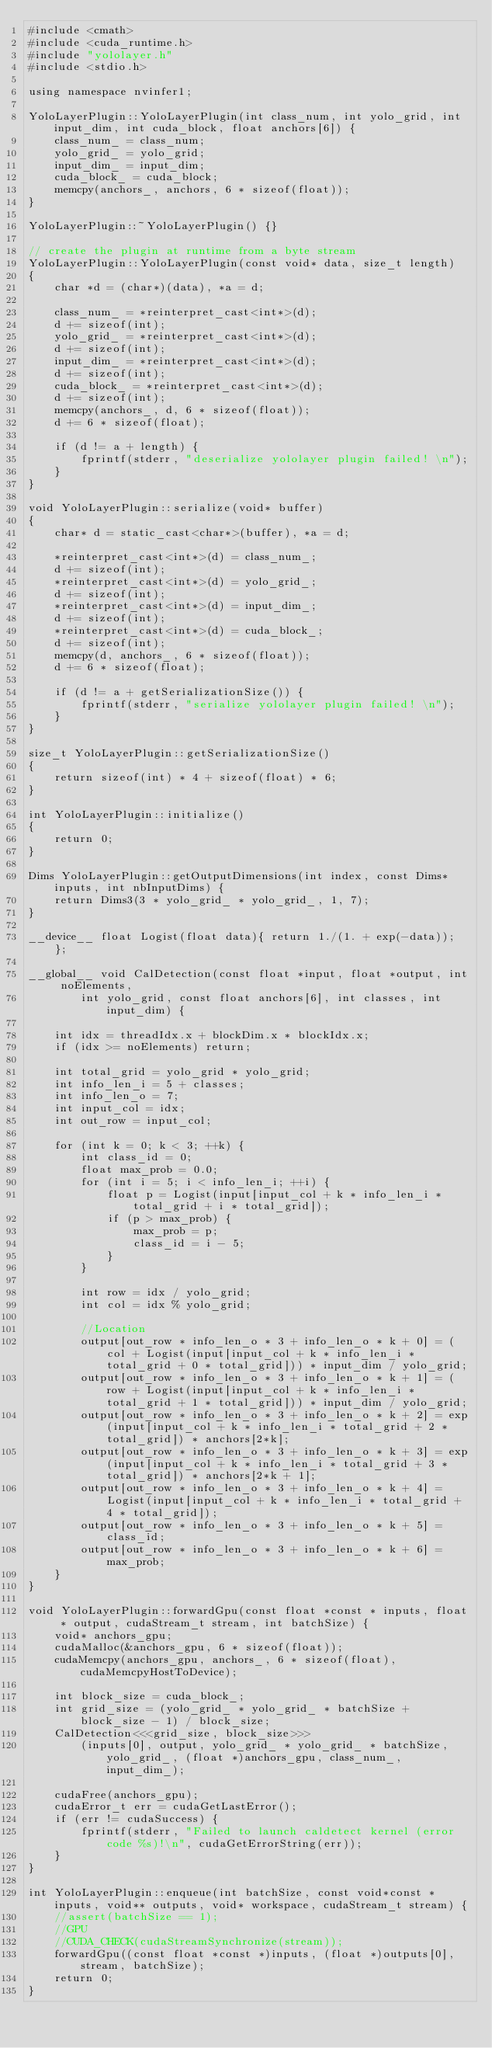Convert code to text. <code><loc_0><loc_0><loc_500><loc_500><_Cuda_>#include <cmath>
#include <cuda_runtime.h>
#include "yololayer.h"
#include <stdio.h>

using namespace nvinfer1;

YoloLayerPlugin::YoloLayerPlugin(int class_num, int yolo_grid, int input_dim, int cuda_block, float anchors[6]) {
    class_num_ = class_num;
    yolo_grid_ = yolo_grid;
    input_dim_ = input_dim;
    cuda_block_ = cuda_block;
    memcpy(anchors_, anchors, 6 * sizeof(float));
}

YoloLayerPlugin::~YoloLayerPlugin() {}

// create the plugin at runtime from a byte stream
YoloLayerPlugin::YoloLayerPlugin(const void* data, size_t length)
{
    char *d = (char*)(data), *a = d;

    class_num_ = *reinterpret_cast<int*>(d);
    d += sizeof(int);
    yolo_grid_ = *reinterpret_cast<int*>(d);
    d += sizeof(int);
    input_dim_ = *reinterpret_cast<int*>(d);
    d += sizeof(int);
    cuda_block_ = *reinterpret_cast<int*>(d);
    d += sizeof(int);
    memcpy(anchors_, d, 6 * sizeof(float));
    d += 6 * sizeof(float);

    if (d != a + length) {
        fprintf(stderr, "deserialize yololayer plugin failed! \n");
    }
}

void YoloLayerPlugin::serialize(void* buffer)
{
    char* d = static_cast<char*>(buffer), *a = d;

    *reinterpret_cast<int*>(d) = class_num_;
    d += sizeof(int);
    *reinterpret_cast<int*>(d) = yolo_grid_;
    d += sizeof(int);
    *reinterpret_cast<int*>(d) = input_dim_;
    d += sizeof(int);
    *reinterpret_cast<int*>(d) = cuda_block_;
    d += sizeof(int);
    memcpy(d, anchors_, 6 * sizeof(float));
    d += 6 * sizeof(float);

    if (d != a + getSerializationSize()) {
        fprintf(stderr, "serialize yololayer plugin failed! \n");
    }
}

size_t YoloLayerPlugin::getSerializationSize()
{  
    return sizeof(int) * 4 + sizeof(float) * 6;
}

int YoloLayerPlugin::initialize()
{ 
    return 0;
}

Dims YoloLayerPlugin::getOutputDimensions(int index, const Dims* inputs, int nbInputDims) {
    return Dims3(3 * yolo_grid_ * yolo_grid_, 1, 7);
}

__device__ float Logist(float data){ return 1./(1. + exp(-data)); };

__global__ void CalDetection(const float *input, float *output, int noElements,
        int yolo_grid, const float anchors[6], int classes, int input_dim) {

    int idx = threadIdx.x + blockDim.x * blockIdx.x;
    if (idx >= noElements) return;

    int total_grid = yolo_grid * yolo_grid;
    int info_len_i = 5 + classes;
    int info_len_o = 7;
    int input_col = idx;
    int out_row = input_col;

    for (int k = 0; k < 3; ++k) {
        int class_id = 0;
        float max_prob = 0.0;
        for (int i = 5; i < info_len_i; ++i) {
            float p = Logist(input[input_col + k * info_len_i * total_grid + i * total_grid]);
            if (p > max_prob) {
                max_prob = p;
                class_id = i - 5;
            }
        }

        int row = idx / yolo_grid;
        int col = idx % yolo_grid;

        //Location
        output[out_row * info_len_o * 3 + info_len_o * k + 0] = (col + Logist(input[input_col + k * info_len_i * total_grid + 0 * total_grid])) * input_dim / yolo_grid;
        output[out_row * info_len_o * 3 + info_len_o * k + 1] = (row + Logist(input[input_col + k * info_len_i * total_grid + 1 * total_grid])) * input_dim / yolo_grid;
        output[out_row * info_len_o * 3 + info_len_o * k + 2] = exp(input[input_col + k * info_len_i * total_grid + 2 * total_grid]) * anchors[2*k];
        output[out_row * info_len_o * 3 + info_len_o * k + 3] = exp(input[input_col + k * info_len_i * total_grid + 3 * total_grid]) * anchors[2*k + 1];
        output[out_row * info_len_o * 3 + info_len_o * k + 4] =  Logist(input[input_col + k * info_len_i * total_grid + 4 * total_grid]);
        output[out_row * info_len_o * 3 + info_len_o * k + 5] =  class_id;
        output[out_row * info_len_o * 3 + info_len_o * k + 6] =  max_prob;
    }
}

void YoloLayerPlugin::forwardGpu(const float *const * inputs, float * output, cudaStream_t stream, int batchSize) {
    void* anchors_gpu;
    cudaMalloc(&anchors_gpu, 6 * sizeof(float));
    cudaMemcpy(anchors_gpu, anchors_, 6 * sizeof(float), cudaMemcpyHostToDevice);

    int block_size = cuda_block_;
    int grid_size = (yolo_grid_ * yolo_grid_ * batchSize + block_size - 1) / block_size;
    CalDetection<<<grid_size, block_size>>>
        (inputs[0], output, yolo_grid_ * yolo_grid_ * batchSize, yolo_grid_, (float *)anchors_gpu, class_num_, input_dim_);

    cudaFree(anchors_gpu);
    cudaError_t err = cudaGetLastError();
    if (err != cudaSuccess) {
        fprintf(stderr, "Failed to launch caldetect kernel (error code %s)!\n", cudaGetErrorString(err));
    }
}

int YoloLayerPlugin::enqueue(int batchSize, const void*const * inputs, void** outputs, void* workspace, cudaStream_t stream) {
    //assert(batchSize == 1);
    //GPU
    //CUDA_CHECK(cudaStreamSynchronize(stream));
    forwardGpu((const float *const *)inputs, (float *)outputs[0], stream, batchSize);
    return 0;
}
</code> 